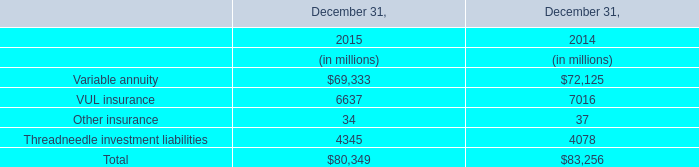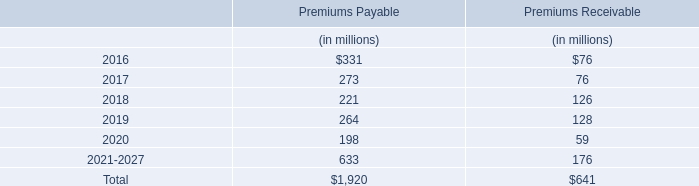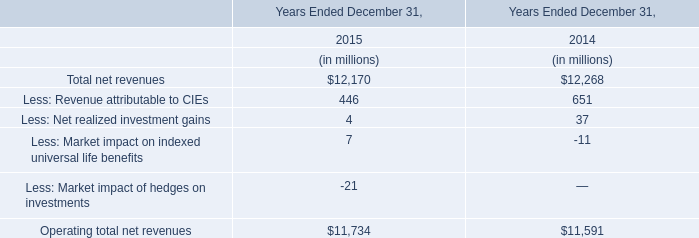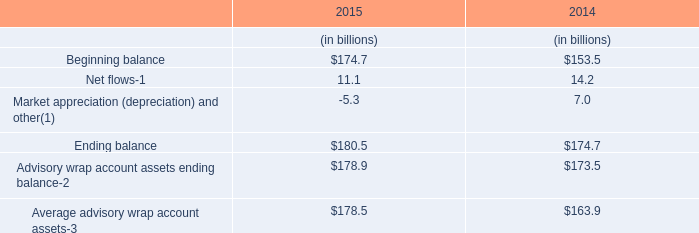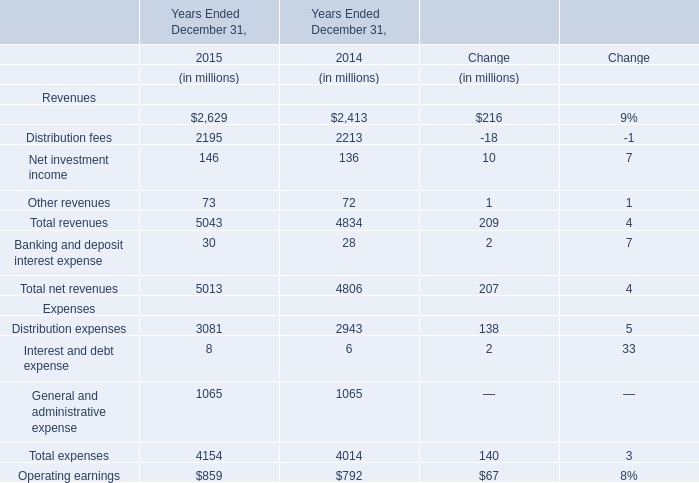Which year is Management and financial advice fees the most? 
Answer: 2015. 